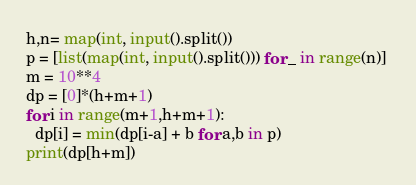Convert code to text. <code><loc_0><loc_0><loc_500><loc_500><_Python_>h,n= map(int, input().split())
p = [list(map(int, input().split())) for _ in range(n)] 
m = 10**4
dp = [0]*(h+m+1)
for i in range(m+1,h+m+1):
  dp[i] = min(dp[i-a] + b for a,b in p)
print(dp[h+m])</code> 